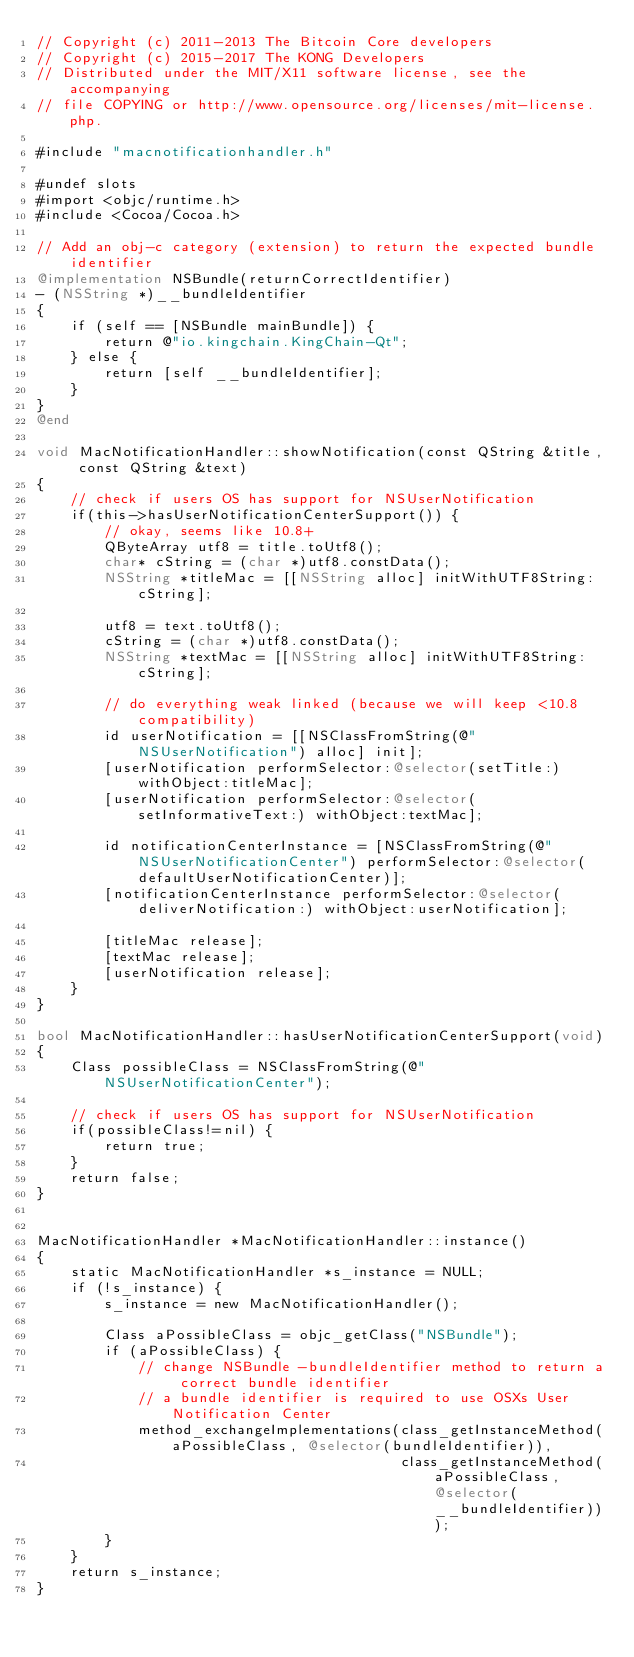<code> <loc_0><loc_0><loc_500><loc_500><_ObjectiveC_>// Copyright (c) 2011-2013 The Bitcoin Core developers
// Copyright (c) 2015-2017 The KONG Developers 
// Distributed under the MIT/X11 software license, see the accompanying
// file COPYING or http://www.opensource.org/licenses/mit-license.php.

#include "macnotificationhandler.h"

#undef slots
#import <objc/runtime.h>
#include <Cocoa/Cocoa.h>

// Add an obj-c category (extension) to return the expected bundle identifier
@implementation NSBundle(returnCorrectIdentifier)
- (NSString *)__bundleIdentifier
{
    if (self == [NSBundle mainBundle]) {
        return @"io.kingchain.KingChain-Qt";
    } else {
        return [self __bundleIdentifier];
    }
}
@end

void MacNotificationHandler::showNotification(const QString &title, const QString &text)
{
    // check if users OS has support for NSUserNotification
    if(this->hasUserNotificationCenterSupport()) {
        // okay, seems like 10.8+
        QByteArray utf8 = title.toUtf8();
        char* cString = (char *)utf8.constData();
        NSString *titleMac = [[NSString alloc] initWithUTF8String:cString];

        utf8 = text.toUtf8();
        cString = (char *)utf8.constData();
        NSString *textMac = [[NSString alloc] initWithUTF8String:cString];

        // do everything weak linked (because we will keep <10.8 compatibility)
        id userNotification = [[NSClassFromString(@"NSUserNotification") alloc] init];
        [userNotification performSelector:@selector(setTitle:) withObject:titleMac];
        [userNotification performSelector:@selector(setInformativeText:) withObject:textMac];

        id notificationCenterInstance = [NSClassFromString(@"NSUserNotificationCenter") performSelector:@selector(defaultUserNotificationCenter)];
        [notificationCenterInstance performSelector:@selector(deliverNotification:) withObject:userNotification];

        [titleMac release];
        [textMac release];
        [userNotification release];
    }
}

bool MacNotificationHandler::hasUserNotificationCenterSupport(void)
{
    Class possibleClass = NSClassFromString(@"NSUserNotificationCenter");

    // check if users OS has support for NSUserNotification
    if(possibleClass!=nil) {
        return true;
    }
    return false;
}


MacNotificationHandler *MacNotificationHandler::instance()
{
    static MacNotificationHandler *s_instance = NULL;
    if (!s_instance) {
        s_instance = new MacNotificationHandler();
        
        Class aPossibleClass = objc_getClass("NSBundle");
        if (aPossibleClass) {
            // change NSBundle -bundleIdentifier method to return a correct bundle identifier
            // a bundle identifier is required to use OSXs User Notification Center
            method_exchangeImplementations(class_getInstanceMethod(aPossibleClass, @selector(bundleIdentifier)),
                                           class_getInstanceMethod(aPossibleClass, @selector(__bundleIdentifier)));
        }
    }
    return s_instance;
}
</code> 